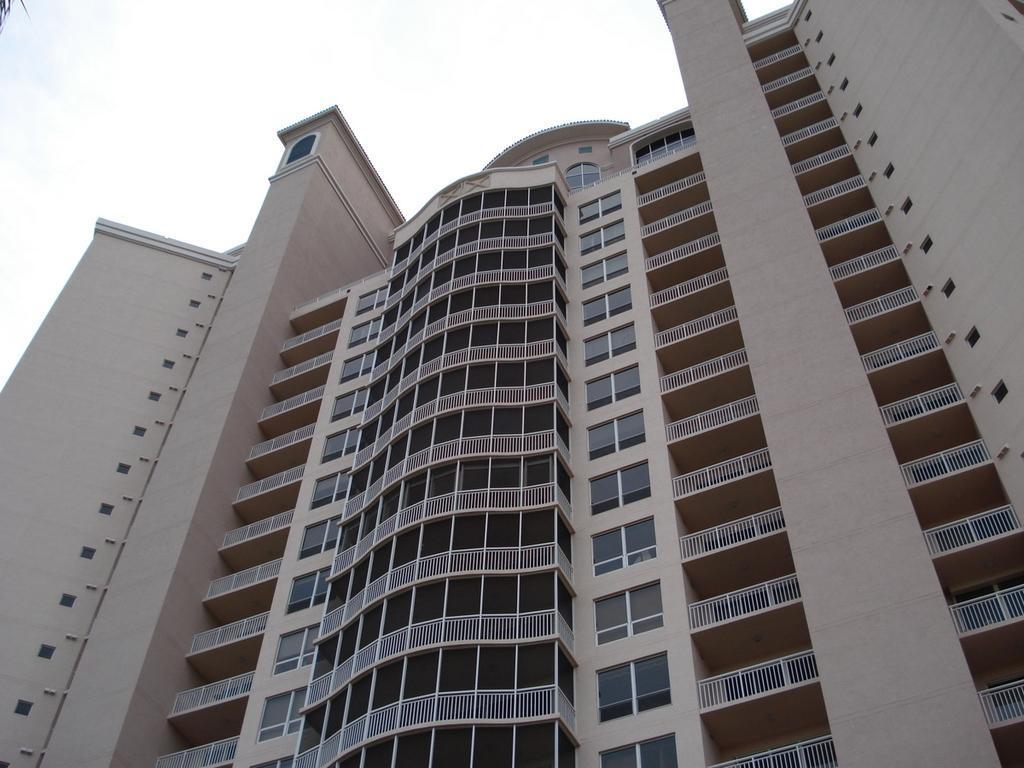What type of structure is visible in the image? There is a building in the image. What are some features of the building? The building has walls, railings, windows, and roofs. What is visible at the top of the image? The sky is visible at the top of the image. What type of arithmetic problem is being solved by the veil in the image? There is no veil or arithmetic problem present in the image; it features a building with various architectural features. 